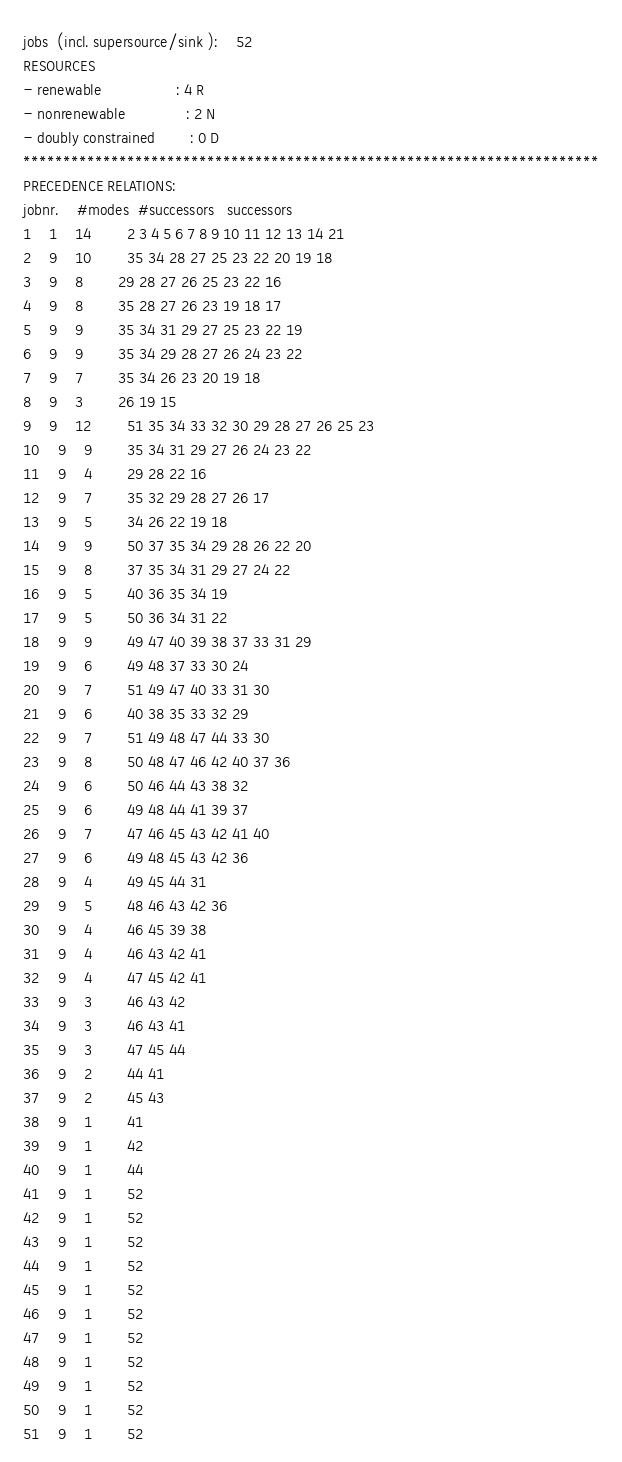<code> <loc_0><loc_0><loc_500><loc_500><_ObjectiveC_>jobs  (incl. supersource/sink ):	52
RESOURCES
- renewable                 : 4 R
- nonrenewable              : 2 N
- doubly constrained        : 0 D
************************************************************************
PRECEDENCE RELATIONS:
jobnr.    #modes  #successors   successors
1	1	14		2 3 4 5 6 7 8 9 10 11 12 13 14 21 
2	9	10		35 34 28 27 25 23 22 20 19 18 
3	9	8		29 28 27 26 25 23 22 16 
4	9	8		35 28 27 26 23 19 18 17 
5	9	9		35 34 31 29 27 25 23 22 19 
6	9	9		35 34 29 28 27 26 24 23 22 
7	9	7		35 34 26 23 20 19 18 
8	9	3		26 19 15 
9	9	12		51 35 34 33 32 30 29 28 27 26 25 23 
10	9	9		35 34 31 29 27 26 24 23 22 
11	9	4		29 28 22 16 
12	9	7		35 32 29 28 27 26 17 
13	9	5		34 26 22 19 18 
14	9	9		50 37 35 34 29 28 26 22 20 
15	9	8		37 35 34 31 29 27 24 22 
16	9	5		40 36 35 34 19 
17	9	5		50 36 34 31 22 
18	9	9		49 47 40 39 38 37 33 31 29 
19	9	6		49 48 37 33 30 24 
20	9	7		51 49 47 40 33 31 30 
21	9	6		40 38 35 33 32 29 
22	9	7		51 49 48 47 44 33 30 
23	9	8		50 48 47 46 42 40 37 36 
24	9	6		50 46 44 43 38 32 
25	9	6		49 48 44 41 39 37 
26	9	7		47 46 45 43 42 41 40 
27	9	6		49 48 45 43 42 36 
28	9	4		49 45 44 31 
29	9	5		48 46 43 42 36 
30	9	4		46 45 39 38 
31	9	4		46 43 42 41 
32	9	4		47 45 42 41 
33	9	3		46 43 42 
34	9	3		46 43 41 
35	9	3		47 45 44 
36	9	2		44 41 
37	9	2		45 43 
38	9	1		41 
39	9	1		42 
40	9	1		44 
41	9	1		52 
42	9	1		52 
43	9	1		52 
44	9	1		52 
45	9	1		52 
46	9	1		52 
47	9	1		52 
48	9	1		52 
49	9	1		52 
50	9	1		52 
51	9	1		52 </code> 